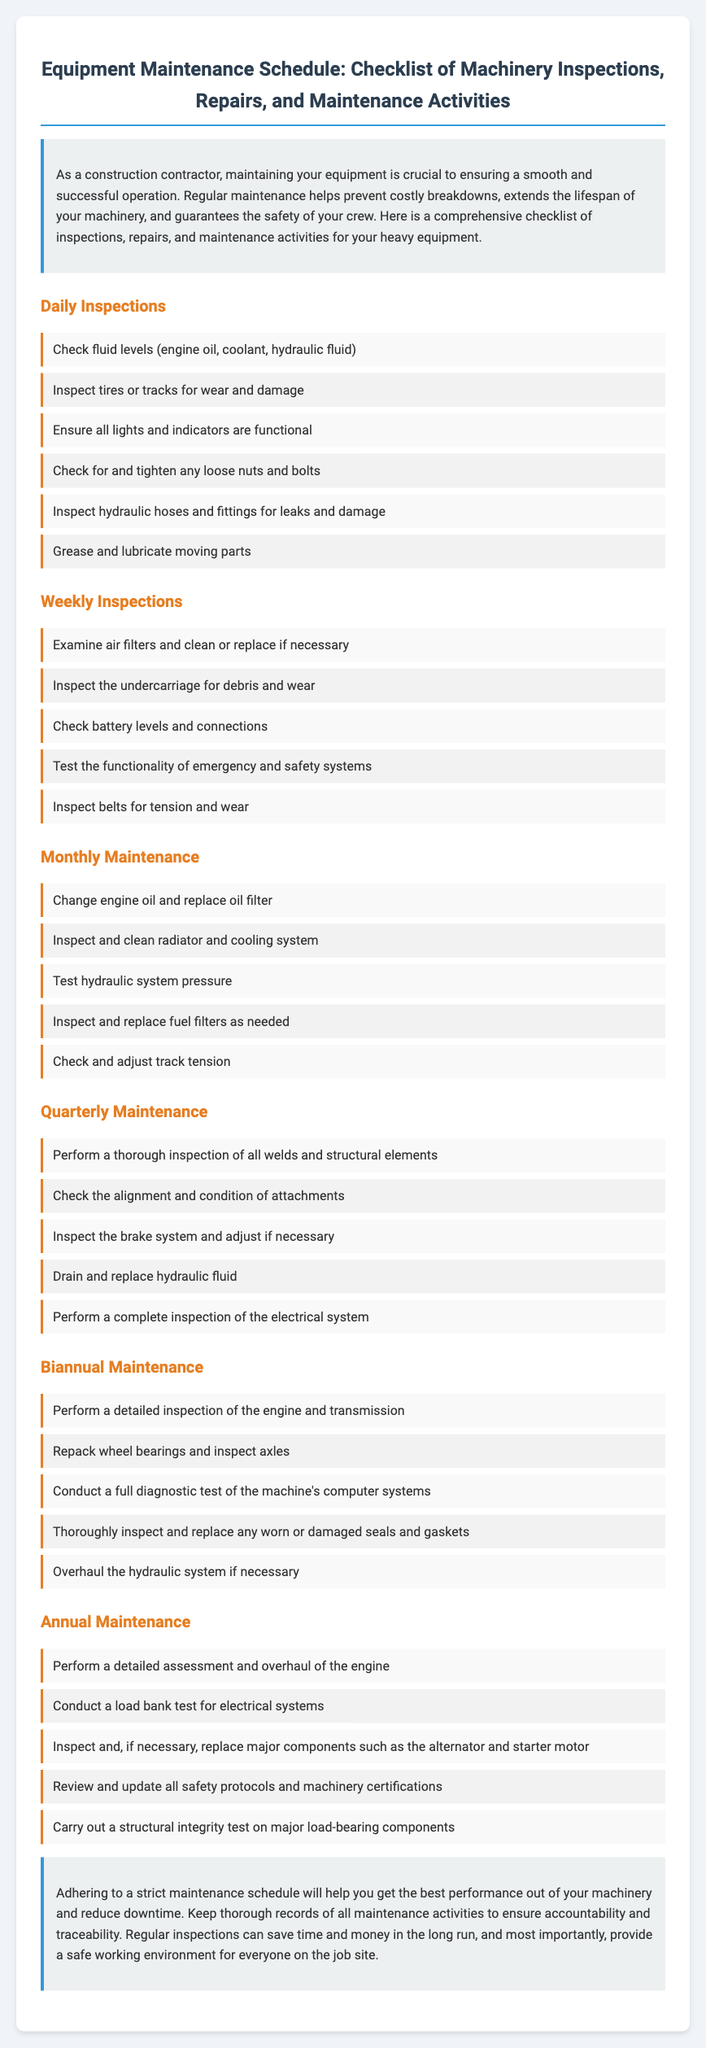what is the title of the document? The title of the document is clearly stated at the top, summarizing its content and purpose.
Answer: Equipment Maintenance Schedule: Checklist of Machinery Inspections, Repairs, and Maintenance Activities how many types of inspections are listed? The document categorizes inspections and maintenance activities into several types, specifically labeled in the headings.
Answer: Six what is the frequency of Daily Inspections? The document specifies that Daily Inspections should be performed every day.
Answer: Daily name one activity included in the Monthly Maintenance section. The Monthly Maintenance section includes specific tasks that should be completed monthly, which are detailed in the list.
Answer: Change engine oil and replace oil filter what is included in the Biannual Maintenance checklist? The checklist for Biannual Maintenance is outlined with specific activities that need to be performed every six months.
Answer: Perform a detailed inspection of the engine and transmission why is regular maintenance emphasized in the document? The introduction and conclusion sections stress the importance of regular maintenance for safety, performance, and cost-efficiency.
Answer: To ensure safety and reduce downtime 